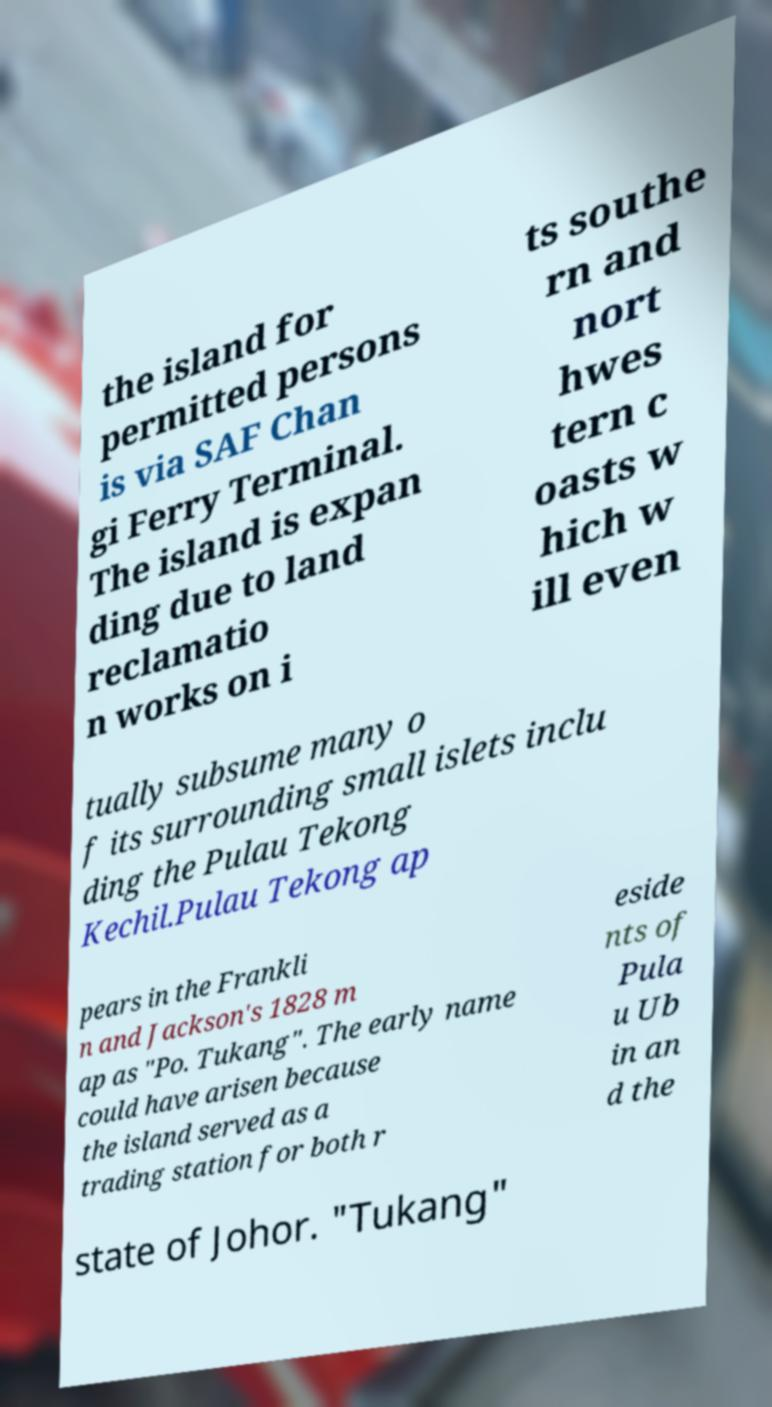What messages or text are displayed in this image? I need them in a readable, typed format. the island for permitted persons is via SAF Chan gi Ferry Terminal. The island is expan ding due to land reclamatio n works on i ts southe rn and nort hwes tern c oasts w hich w ill even tually subsume many o f its surrounding small islets inclu ding the Pulau Tekong Kechil.Pulau Tekong ap pears in the Frankli n and Jackson's 1828 m ap as "Po. Tukang". The early name could have arisen because the island served as a trading station for both r eside nts of Pula u Ub in an d the state of Johor. "Tukang" 